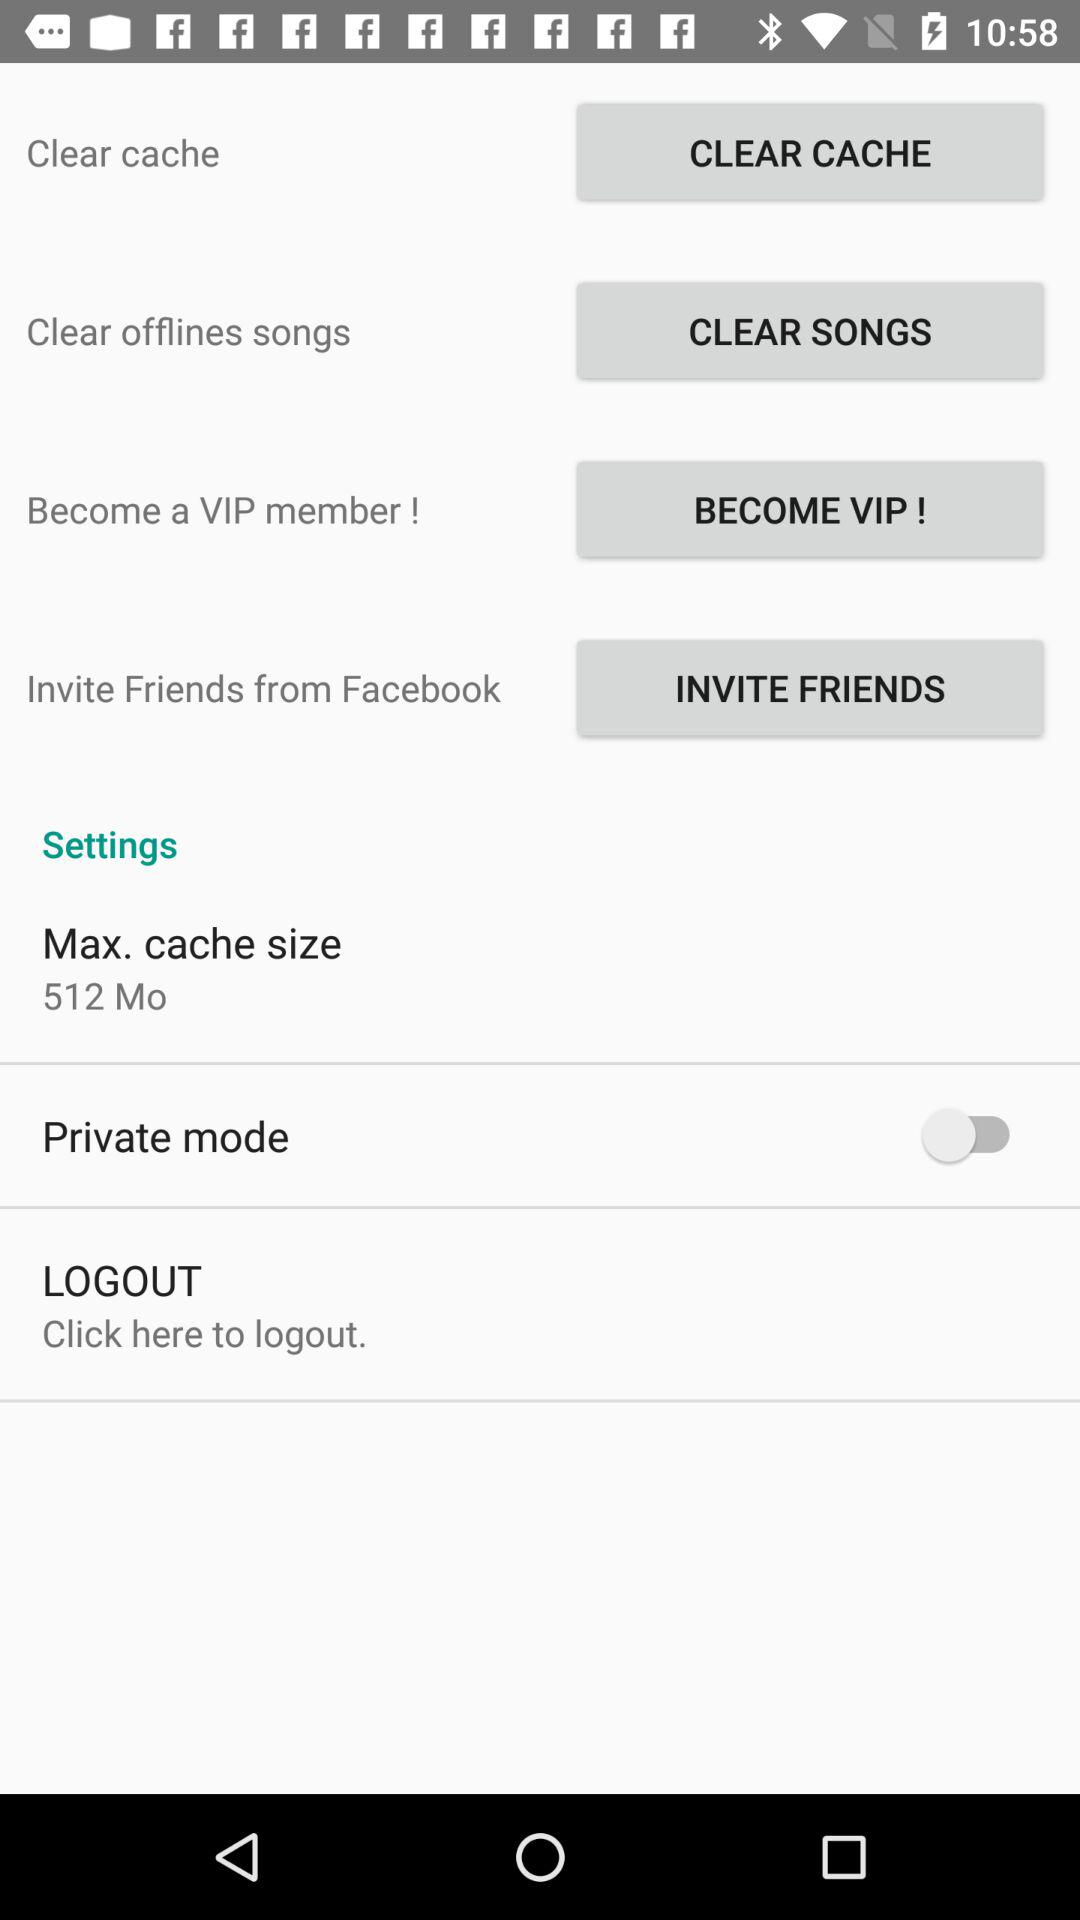What is the maximum size of the cache? The maximum size of the cache is 512 Mo. 